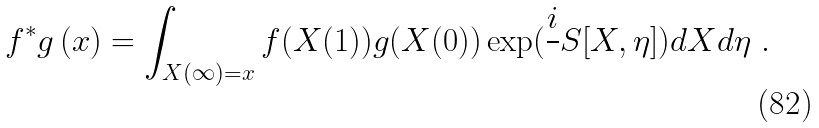Convert formula to latex. <formula><loc_0><loc_0><loc_500><loc_500>f ^ { * } g \, ( x ) = \int _ { X ( \infty ) = x } f ( X ( 1 ) ) g ( X ( 0 ) ) \exp ( \frac { i } { } S [ X , \eta ] ) d X d \eta \ .</formula> 